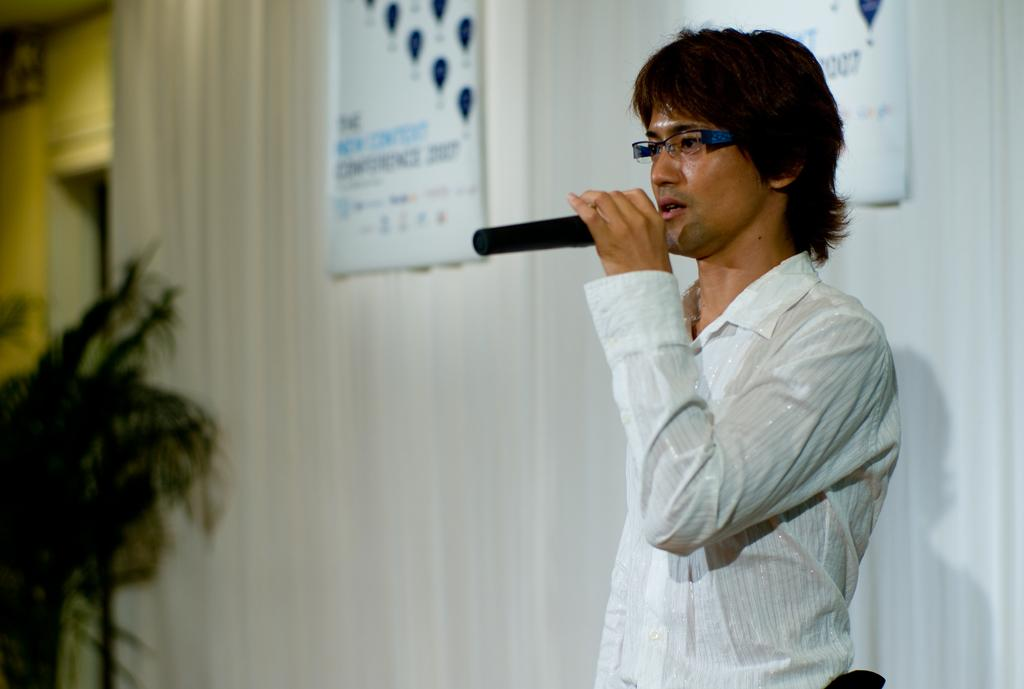What is the main subject of the image? The main subject of the image is a man. What is the man doing in the image? The man is standing in the image. What object is the man holding in his hand? The man is holding a mic in his hand. What book is the man reading in the image? There is no book present in the image, and the man is not shown reading. What type of slave is depicted in the image? There is no depiction of a slave in the image; it features a man standing and holding a mic. 